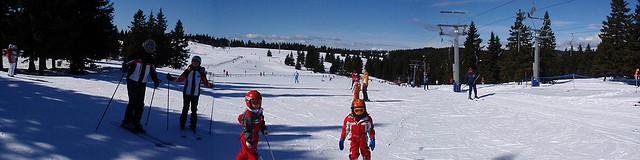What is casting a shadow over the people?
Short answer required. Trees. What's covering the ground?
Concise answer only. Snow. Do all people seem to be wearing safety gear?
Keep it brief. Yes. 